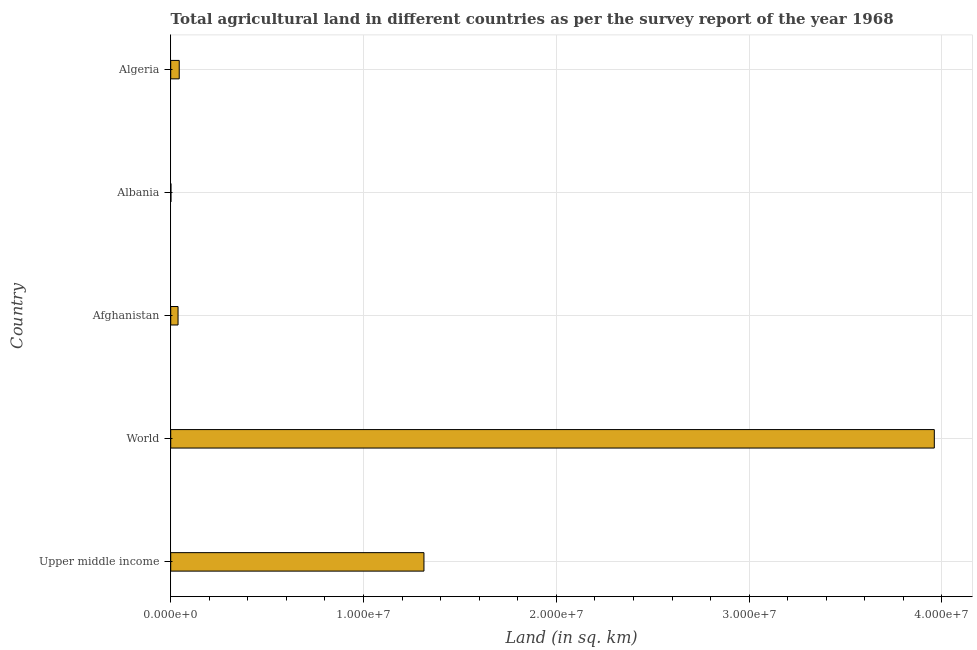Does the graph contain any zero values?
Your response must be concise. No. What is the title of the graph?
Your answer should be very brief. Total agricultural land in different countries as per the survey report of the year 1968. What is the label or title of the X-axis?
Offer a very short reply. Land (in sq. km). What is the label or title of the Y-axis?
Give a very brief answer. Country. What is the agricultural land in Algeria?
Offer a terse response. 4.42e+05. Across all countries, what is the maximum agricultural land?
Offer a very short reply. 3.96e+07. Across all countries, what is the minimum agricultural land?
Make the answer very short. 1.24e+04. In which country was the agricultural land minimum?
Your answer should be compact. Albania. What is the sum of the agricultural land?
Make the answer very short. 5.36e+07. What is the difference between the agricultural land in Albania and Upper middle income?
Provide a succinct answer. -1.31e+07. What is the average agricultural land per country?
Provide a short and direct response. 1.07e+07. What is the median agricultural land?
Your response must be concise. 4.42e+05. What is the ratio of the agricultural land in Algeria to that in Upper middle income?
Give a very brief answer. 0.03. Is the difference between the agricultural land in Afghanistan and Upper middle income greater than the difference between any two countries?
Give a very brief answer. No. What is the difference between the highest and the second highest agricultural land?
Provide a short and direct response. 2.65e+07. Is the sum of the agricultural land in Albania and Upper middle income greater than the maximum agricultural land across all countries?
Offer a very short reply. No. What is the difference between the highest and the lowest agricultural land?
Provide a short and direct response. 3.96e+07. How many bars are there?
Make the answer very short. 5. Are the values on the major ticks of X-axis written in scientific E-notation?
Your response must be concise. Yes. What is the Land (in sq. km) of Upper middle income?
Keep it short and to the point. 1.31e+07. What is the Land (in sq. km) of World?
Provide a succinct answer. 3.96e+07. What is the Land (in sq. km) of Afghanistan?
Keep it short and to the point. 3.80e+05. What is the Land (in sq. km) in Albania?
Provide a short and direct response. 1.24e+04. What is the Land (in sq. km) of Algeria?
Your response must be concise. 4.42e+05. What is the difference between the Land (in sq. km) in Upper middle income and World?
Provide a succinct answer. -2.65e+07. What is the difference between the Land (in sq. km) in Upper middle income and Afghanistan?
Offer a terse response. 1.28e+07. What is the difference between the Land (in sq. km) in Upper middle income and Albania?
Give a very brief answer. 1.31e+07. What is the difference between the Land (in sq. km) in Upper middle income and Algeria?
Your answer should be compact. 1.27e+07. What is the difference between the Land (in sq. km) in World and Afghanistan?
Offer a very short reply. 3.92e+07. What is the difference between the Land (in sq. km) in World and Albania?
Your response must be concise. 3.96e+07. What is the difference between the Land (in sq. km) in World and Algeria?
Offer a very short reply. 3.92e+07. What is the difference between the Land (in sq. km) in Afghanistan and Albania?
Your answer should be compact. 3.67e+05. What is the difference between the Land (in sq. km) in Afghanistan and Algeria?
Offer a very short reply. -6.22e+04. What is the difference between the Land (in sq. km) in Albania and Algeria?
Your answer should be very brief. -4.30e+05. What is the ratio of the Land (in sq. km) in Upper middle income to that in World?
Make the answer very short. 0.33. What is the ratio of the Land (in sq. km) in Upper middle income to that in Afghanistan?
Keep it short and to the point. 34.58. What is the ratio of the Land (in sq. km) in Upper middle income to that in Albania?
Provide a short and direct response. 1059.26. What is the ratio of the Land (in sq. km) in Upper middle income to that in Algeria?
Give a very brief answer. 29.71. What is the ratio of the Land (in sq. km) in World to that in Afghanistan?
Offer a terse response. 104.28. What is the ratio of the Land (in sq. km) in World to that in Albania?
Keep it short and to the point. 3194.01. What is the ratio of the Land (in sq. km) in World to that in Algeria?
Your answer should be compact. 89.6. What is the ratio of the Land (in sq. km) in Afghanistan to that in Albania?
Ensure brevity in your answer.  30.63. What is the ratio of the Land (in sq. km) in Afghanistan to that in Algeria?
Provide a short and direct response. 0.86. What is the ratio of the Land (in sq. km) in Albania to that in Algeria?
Your answer should be very brief. 0.03. 